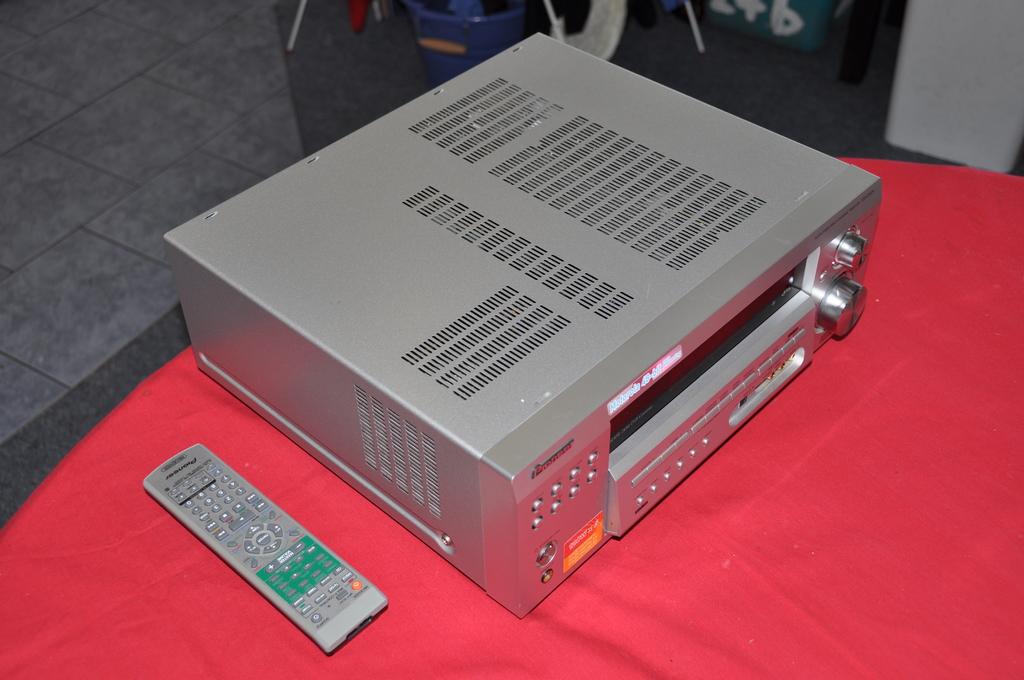What company made the remote control?
Provide a succinct answer. Unanswerable. 